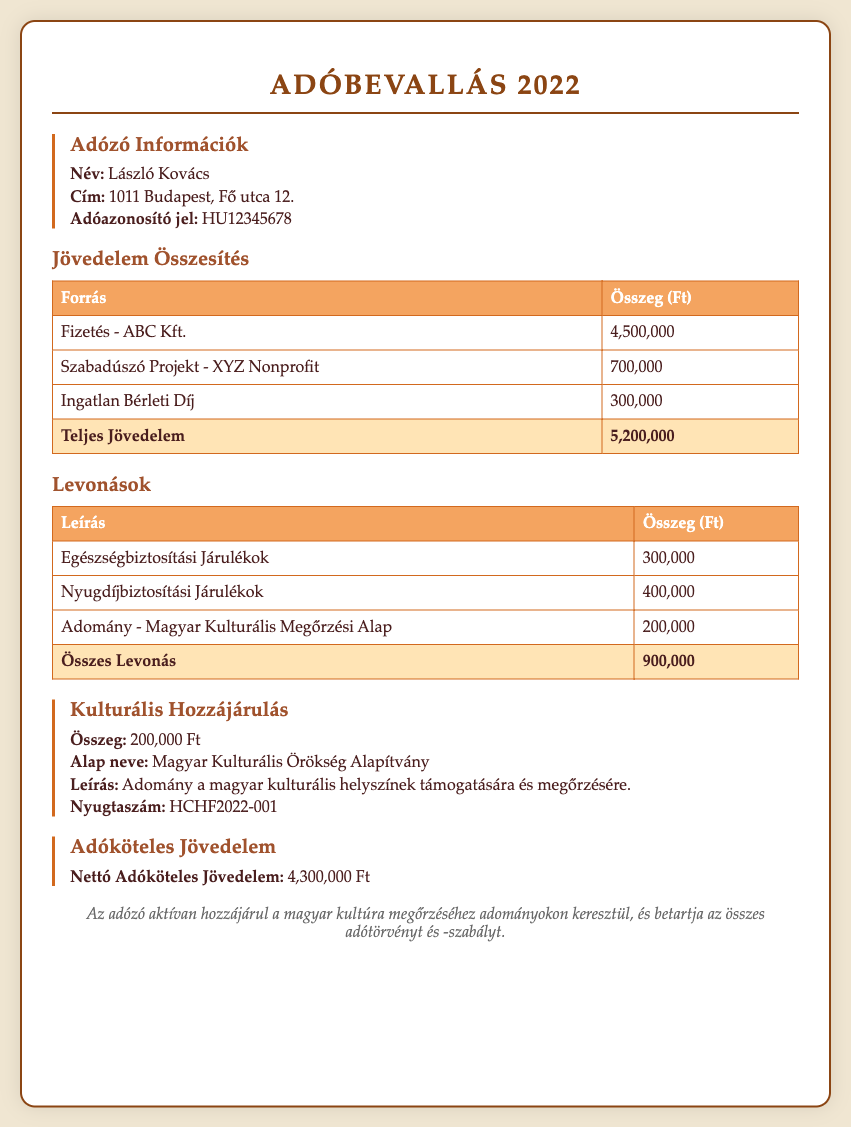what is the name of the taxpayer? The name of the taxpayer, as indicated in the document, is László Kovács.
Answer: László Kovács what is the total income reported? The total income is listed in the income summary table, which sums up to 5,200,000 Ft.
Answer: 5,200,000 Ft how much was contributed to the Hungarian Cultural Preservation Fund? The document states that an amount of 200,000 Ft was contributed to the fund for cultural preservation.
Answer: 200,000 Ft what is the sum of total deductions? The total deductions can be found in the deductions table, totaling 900,000 Ft.
Answer: 900,000 Ft what is the net taxable income? The net taxable income is specified in the tax document as 4,300,000 Ft.
Answer: 4,300,000 Ft what type of contributions are highlighted in this document? The document emphasizes contributions to the Magyar Kulturális Örökség Alapítvány, which is a cultural heritage foundation.
Answer: Magyar Kulturális Örökség Alapítvány what is the address of this taxpayer? The taxpayer's address can be found in the information section, which states 1011 Budapest, Fő utca 12.
Answer: 1011 Budapest, Fő utca 12 how many types of income are listed? The income sources listed include three types: salary, freelance project, and rental income.
Answer: three types what is the purpose of the donation mentioned? The donation is aimed at supporting and preserving Hungarian cultural sites.
Answer: supporting and preserving Hungarian cultural sites 